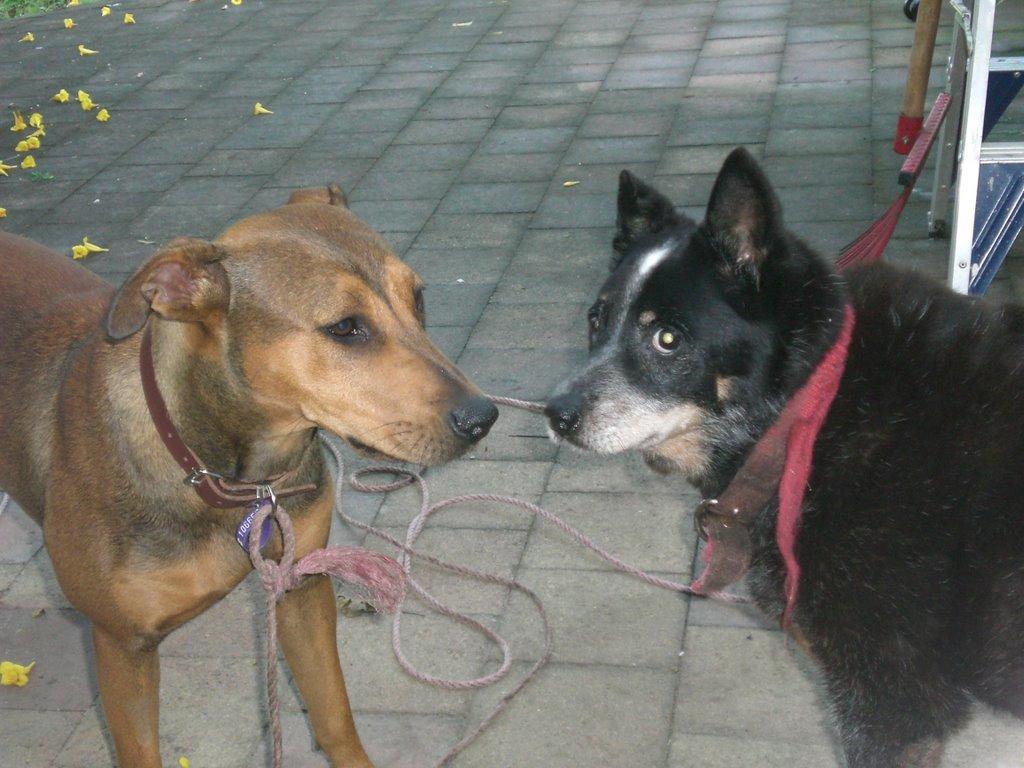Describe this image in one or two sentences. In this image, on the right side, we can see a black color dog, on which its collar rope is tied to a metal rod. On the left side, we can also see another dog. In the background, we can see some flowers which are placed on the floor. 